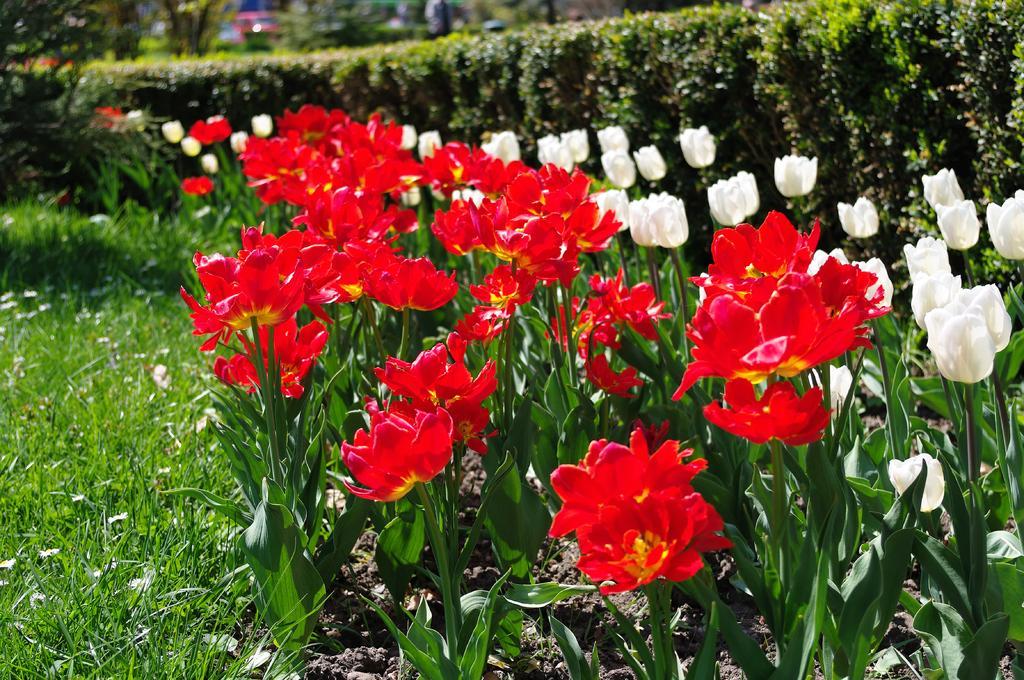Describe this image in one or two sentences. In this image there are plants and hedges on the ground. To the left there's grass on the ground. There are flowers to the plants. There are tulips in the image. 